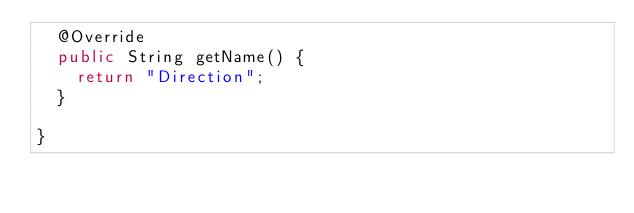<code> <loc_0><loc_0><loc_500><loc_500><_Java_>	@Override
	public String getName() {
		return "Direction";
	}

}
</code> 